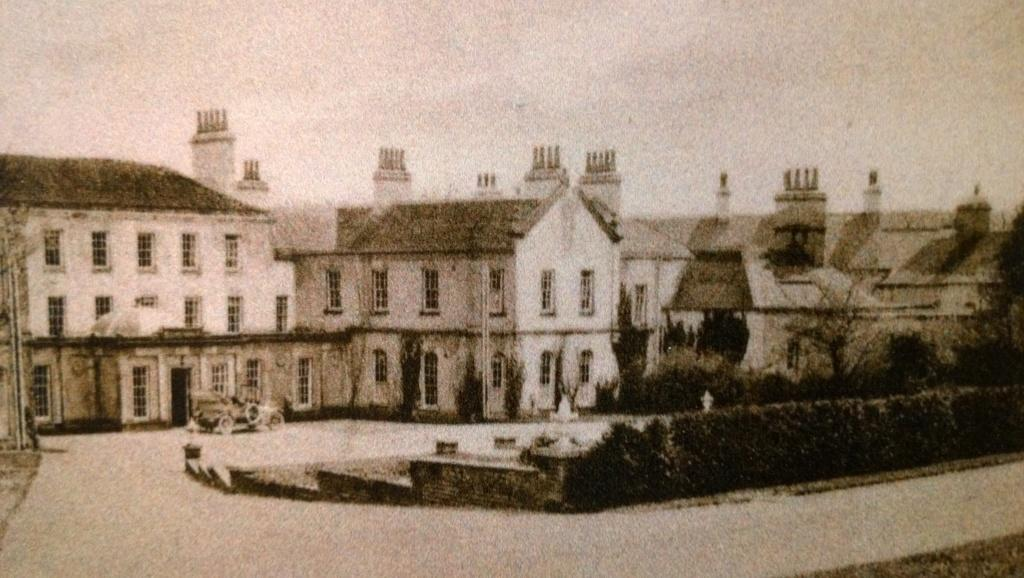What type of photograph is the image? The image is a black and white photograph. What can be seen on the ground in the photograph? There are motor vehicles on the ground in the photograph. What structures are visible in the photograph? There are buildings in the photograph. What part of the natural environment is visible in the photograph? The sky is visible in the photograph. What type of vegetation is present in the photograph? Bushes and trees are visible in the photograph. What type of ice can be seen melting on the roof of the building in the photograph? There is no ice visible in the photograph, as it is a black and white image. What type of army is present in the photograph? There is no army present in the photograph; it features motor vehicles, buildings, and vegetation. 